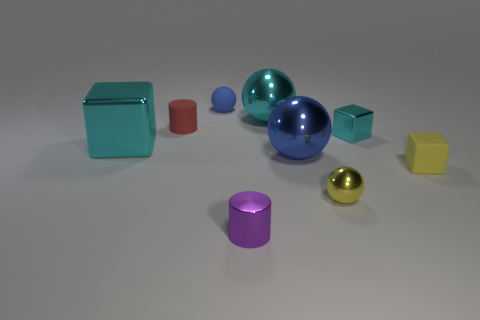Add 1 large things. How many objects exist? 10 Subtract all cylinders. How many objects are left? 7 Subtract all small purple things. Subtract all big objects. How many objects are left? 5 Add 7 tiny matte objects. How many tiny matte objects are left? 10 Add 7 small gray blocks. How many small gray blocks exist? 7 Subtract 2 blue spheres. How many objects are left? 7 